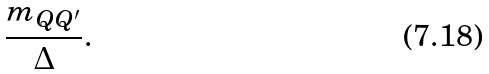Convert formula to latex. <formula><loc_0><loc_0><loc_500><loc_500>\frac { m _ { Q Q ^ { \prime } } } { \Delta } .</formula> 